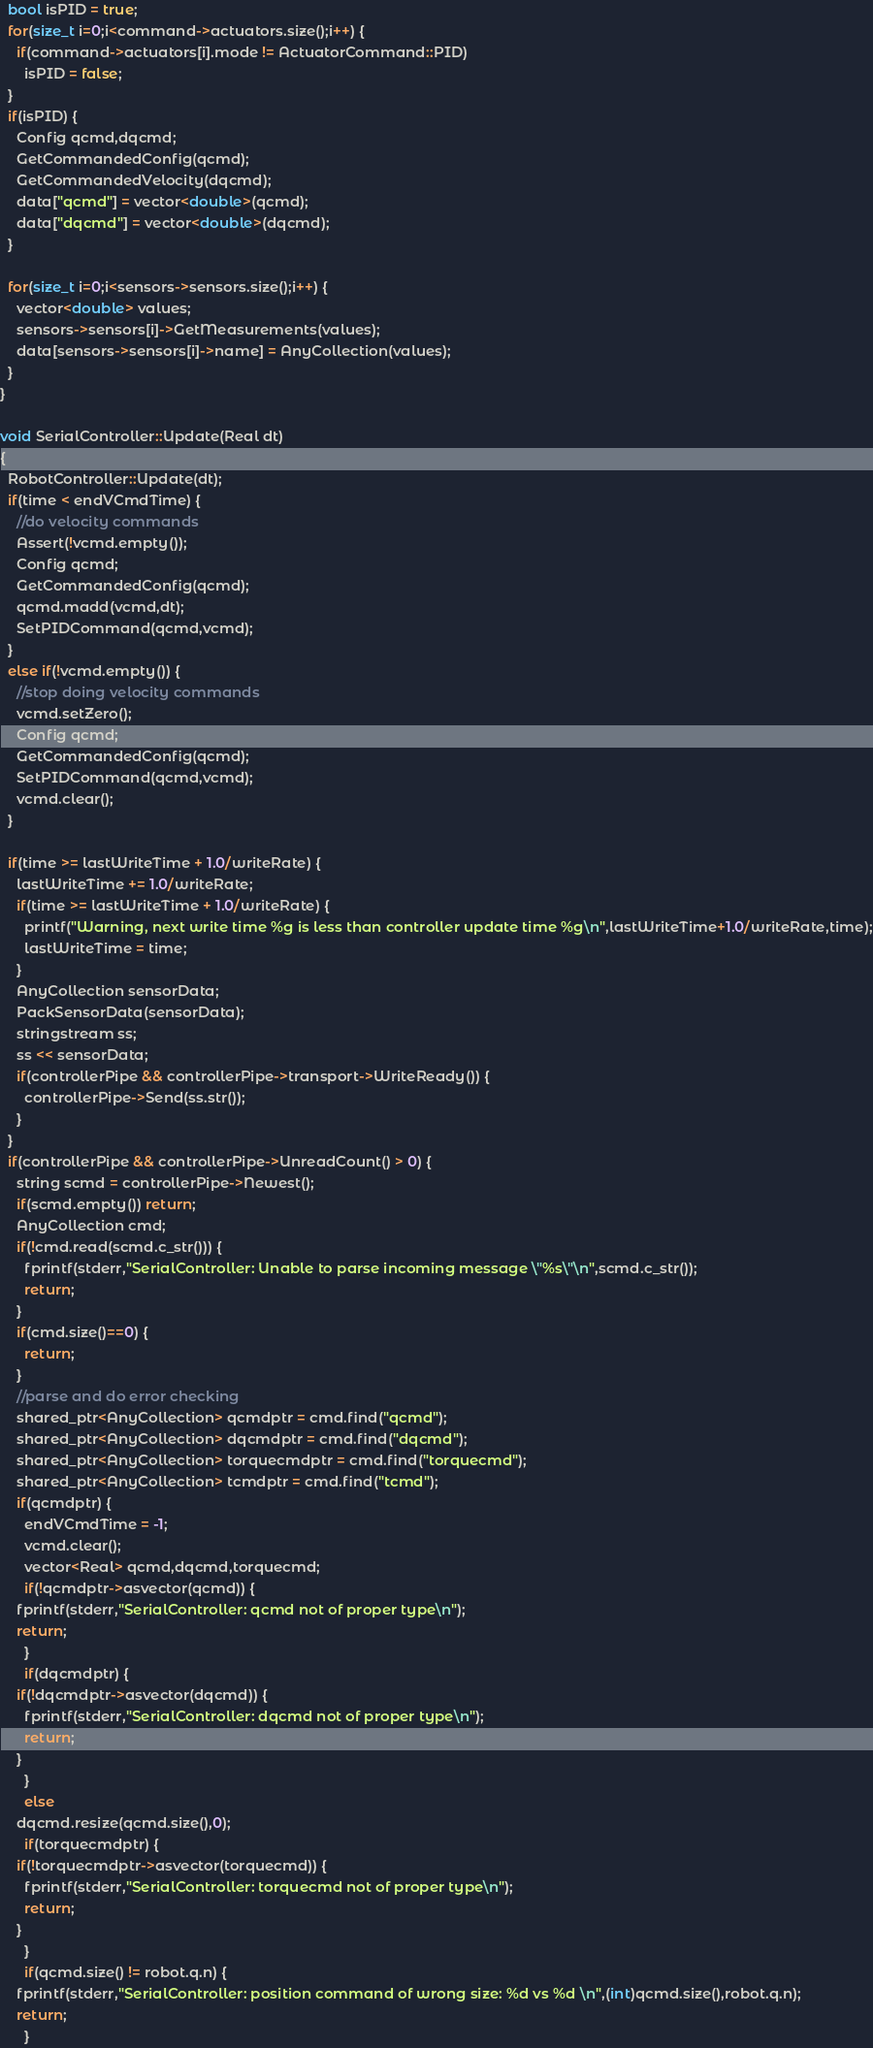<code> <loc_0><loc_0><loc_500><loc_500><_C++_>
  bool isPID = true;
  for(size_t i=0;i<command->actuators.size();i++) {
    if(command->actuators[i].mode != ActuatorCommand::PID)
      isPID = false;
  }
  if(isPID) {
    Config qcmd,dqcmd;
    GetCommandedConfig(qcmd);
    GetCommandedVelocity(dqcmd);
    data["qcmd"] = vector<double>(qcmd);
    data["dqcmd"] = vector<double>(dqcmd);
  }

  for(size_t i=0;i<sensors->sensors.size();i++) {
    vector<double> values;
    sensors->sensors[i]->GetMeasurements(values);
    data[sensors->sensors[i]->name] = AnyCollection(values);
  }
}

void SerialController::Update(Real dt)
{
  RobotController::Update(dt);
  if(time < endVCmdTime) {
    //do velocity commands
    Assert(!vcmd.empty());
    Config qcmd;
    GetCommandedConfig(qcmd);
    qcmd.madd(vcmd,dt);
    SetPIDCommand(qcmd,vcmd);
  }
  else if(!vcmd.empty()) {
    //stop doing velocity commands
    vcmd.setZero();
    Config qcmd;
    GetCommandedConfig(qcmd);
    SetPIDCommand(qcmd,vcmd);
    vcmd.clear();
  }

  if(time >= lastWriteTime + 1.0/writeRate) {
    lastWriteTime += 1.0/writeRate;
    if(time >= lastWriteTime + 1.0/writeRate) {
      printf("Warning, next write time %g is less than controller update time %g\n",lastWriteTime+1.0/writeRate,time);
      lastWriteTime = time;
    }
    AnyCollection sensorData;
    PackSensorData(sensorData);
    stringstream ss;
    ss << sensorData;
    if(controllerPipe && controllerPipe->transport->WriteReady()) {
      controllerPipe->Send(ss.str());
    }
  }
  if(controllerPipe && controllerPipe->UnreadCount() > 0) {
    string scmd = controllerPipe->Newest();
    if(scmd.empty()) return;
    AnyCollection cmd;
    if(!cmd.read(scmd.c_str())) {
      fprintf(stderr,"SerialController: Unable to parse incoming message \"%s\"\n",scmd.c_str());
      return;
    }
    if(cmd.size()==0) {
      return;
    }
    //parse and do error checking
    shared_ptr<AnyCollection> qcmdptr = cmd.find("qcmd");
    shared_ptr<AnyCollection> dqcmdptr = cmd.find("dqcmd");
    shared_ptr<AnyCollection> torquecmdptr = cmd.find("torquecmd");
    shared_ptr<AnyCollection> tcmdptr = cmd.find("tcmd");
    if(qcmdptr) {
      endVCmdTime = -1;
      vcmd.clear();
      vector<Real> qcmd,dqcmd,torquecmd;
      if(!qcmdptr->asvector(qcmd)) {
	fprintf(stderr,"SerialController: qcmd not of proper type\n");
	return;
      }
      if(dqcmdptr) {
	if(!dqcmdptr->asvector(dqcmd)) {
	  fprintf(stderr,"SerialController: dqcmd not of proper type\n");
	  return;
	}
      }
      else
	dqcmd.resize(qcmd.size(),0);
      if(torquecmdptr) {
	if(!torquecmdptr->asvector(torquecmd)) {
	  fprintf(stderr,"SerialController: torquecmd not of proper type\n");
	  return;
	}
      }
      if(qcmd.size() != robot.q.n) {
	fprintf(stderr,"SerialController: position command of wrong size: %d vs %d \n",(int)qcmd.size(),robot.q.n);
	return;
      }</code> 